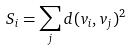<formula> <loc_0><loc_0><loc_500><loc_500>S _ { i } = \sum _ { j } d ( v _ { i } , v _ { j } ) ^ { 2 }</formula> 